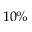<formula> <loc_0><loc_0><loc_500><loc_500>1 0 \%</formula> 